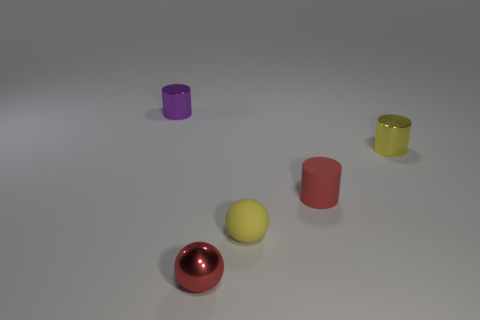Subtract all tiny rubber cylinders. How many cylinders are left? 2 Add 1 large yellow cylinders. How many objects exist? 6 Subtract 1 cylinders. How many cylinders are left? 2 Subtract all cyan cylinders. Subtract all gray balls. How many cylinders are left? 3 Subtract all balls. How many objects are left? 3 Subtract all tiny purple metal things. Subtract all purple objects. How many objects are left? 3 Add 1 red balls. How many red balls are left? 2 Add 4 matte cylinders. How many matte cylinders exist? 5 Subtract 1 yellow cylinders. How many objects are left? 4 